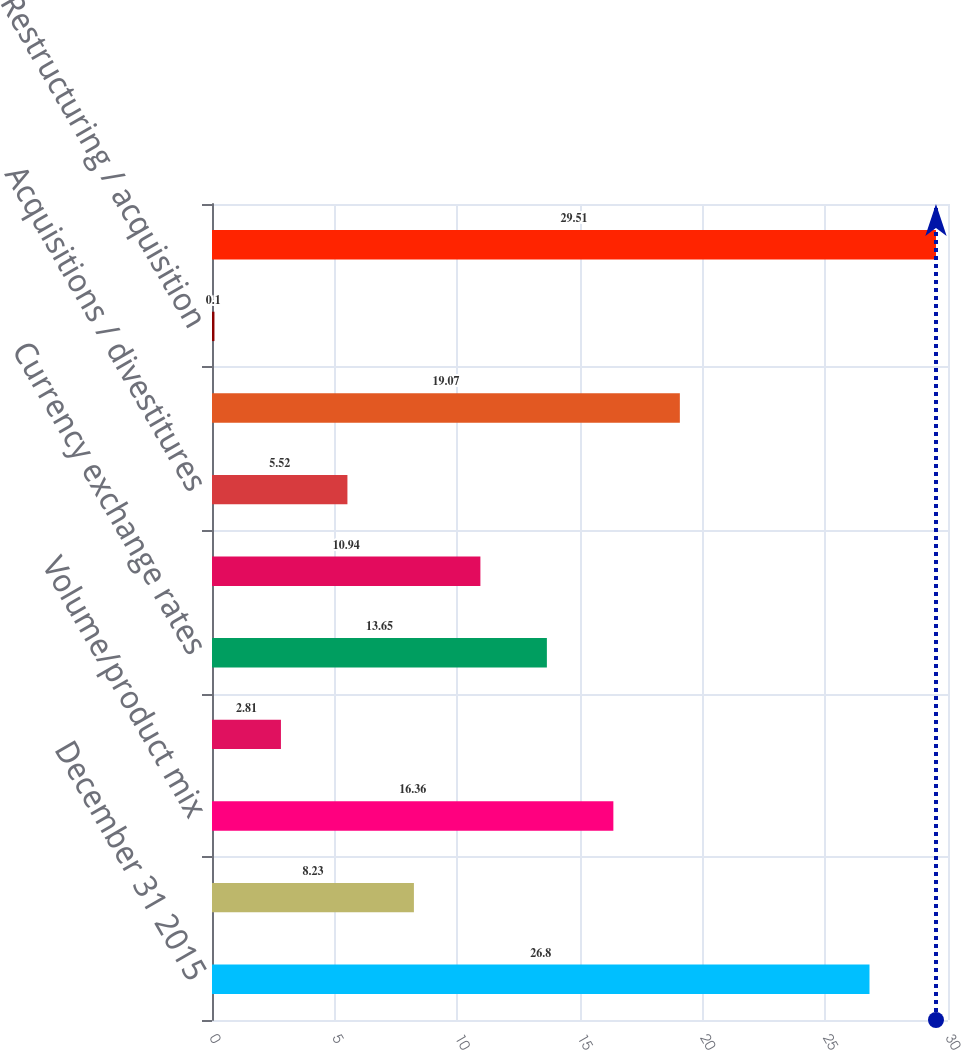Convert chart to OTSL. <chart><loc_0><loc_0><loc_500><loc_500><bar_chart><fcel>December 31 2015<fcel>Pricing and productivity in<fcel>Volume/product mix<fcel>Non-cash inventory impairment<fcel>Currency exchange rates<fcel>Investment spending<fcel>Acquisitions / divestitures<fcel>Environmental remediation<fcel>Restructuring / acquisition<fcel>December 31 2016<nl><fcel>26.8<fcel>8.23<fcel>16.36<fcel>2.81<fcel>13.65<fcel>10.94<fcel>5.52<fcel>19.07<fcel>0.1<fcel>29.51<nl></chart> 